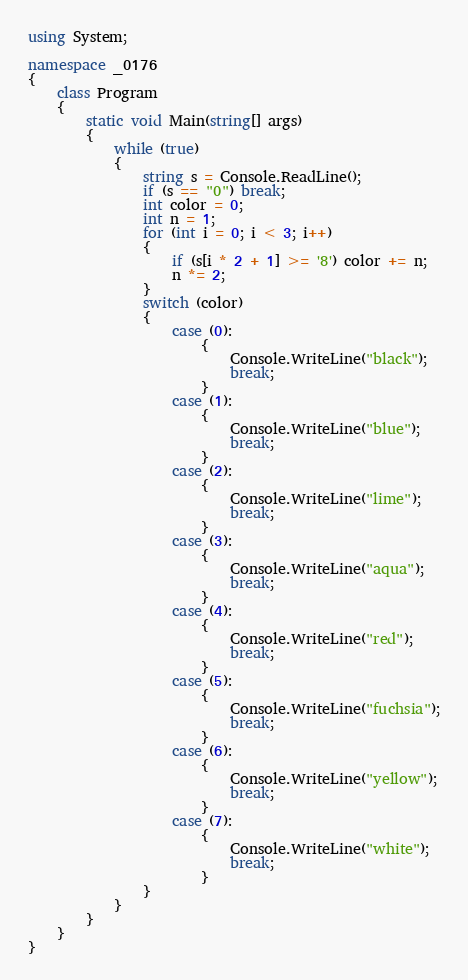<code> <loc_0><loc_0><loc_500><loc_500><_C#_>using System;

namespace _0176
{
    class Program
    {
        static void Main(string[] args)
        {
            while (true)
            {
                string s = Console.ReadLine();
                if (s == "0") break;
                int color = 0;
                int n = 1;
                for (int i = 0; i < 3; i++)
                {
                    if (s[i * 2 + 1] >= '8') color += n;
                    n *= 2;
                }
                switch (color)
                {
                    case (0):
                        {
                            Console.WriteLine("black");
                            break;
                        }
                    case (1):
                        {
                            Console.WriteLine("blue");
                            break;
                        }
                    case (2):
                        {
                            Console.WriteLine("lime");
                            break;
                        }
                    case (3):
                        {
                            Console.WriteLine("aqua");
                            break;
                        }
                    case (4):
                        {
                            Console.WriteLine("red");
                            break;
                        }
                    case (5):
                        {
                            Console.WriteLine("fuchsia");
                            break;
                        }
                    case (6):
                        {
                            Console.WriteLine("yellow");
                            break;
                        }
                    case (7):
                        {
                            Console.WriteLine("white");
                            break;
                        }
                }
            }
        }
    }
}</code> 